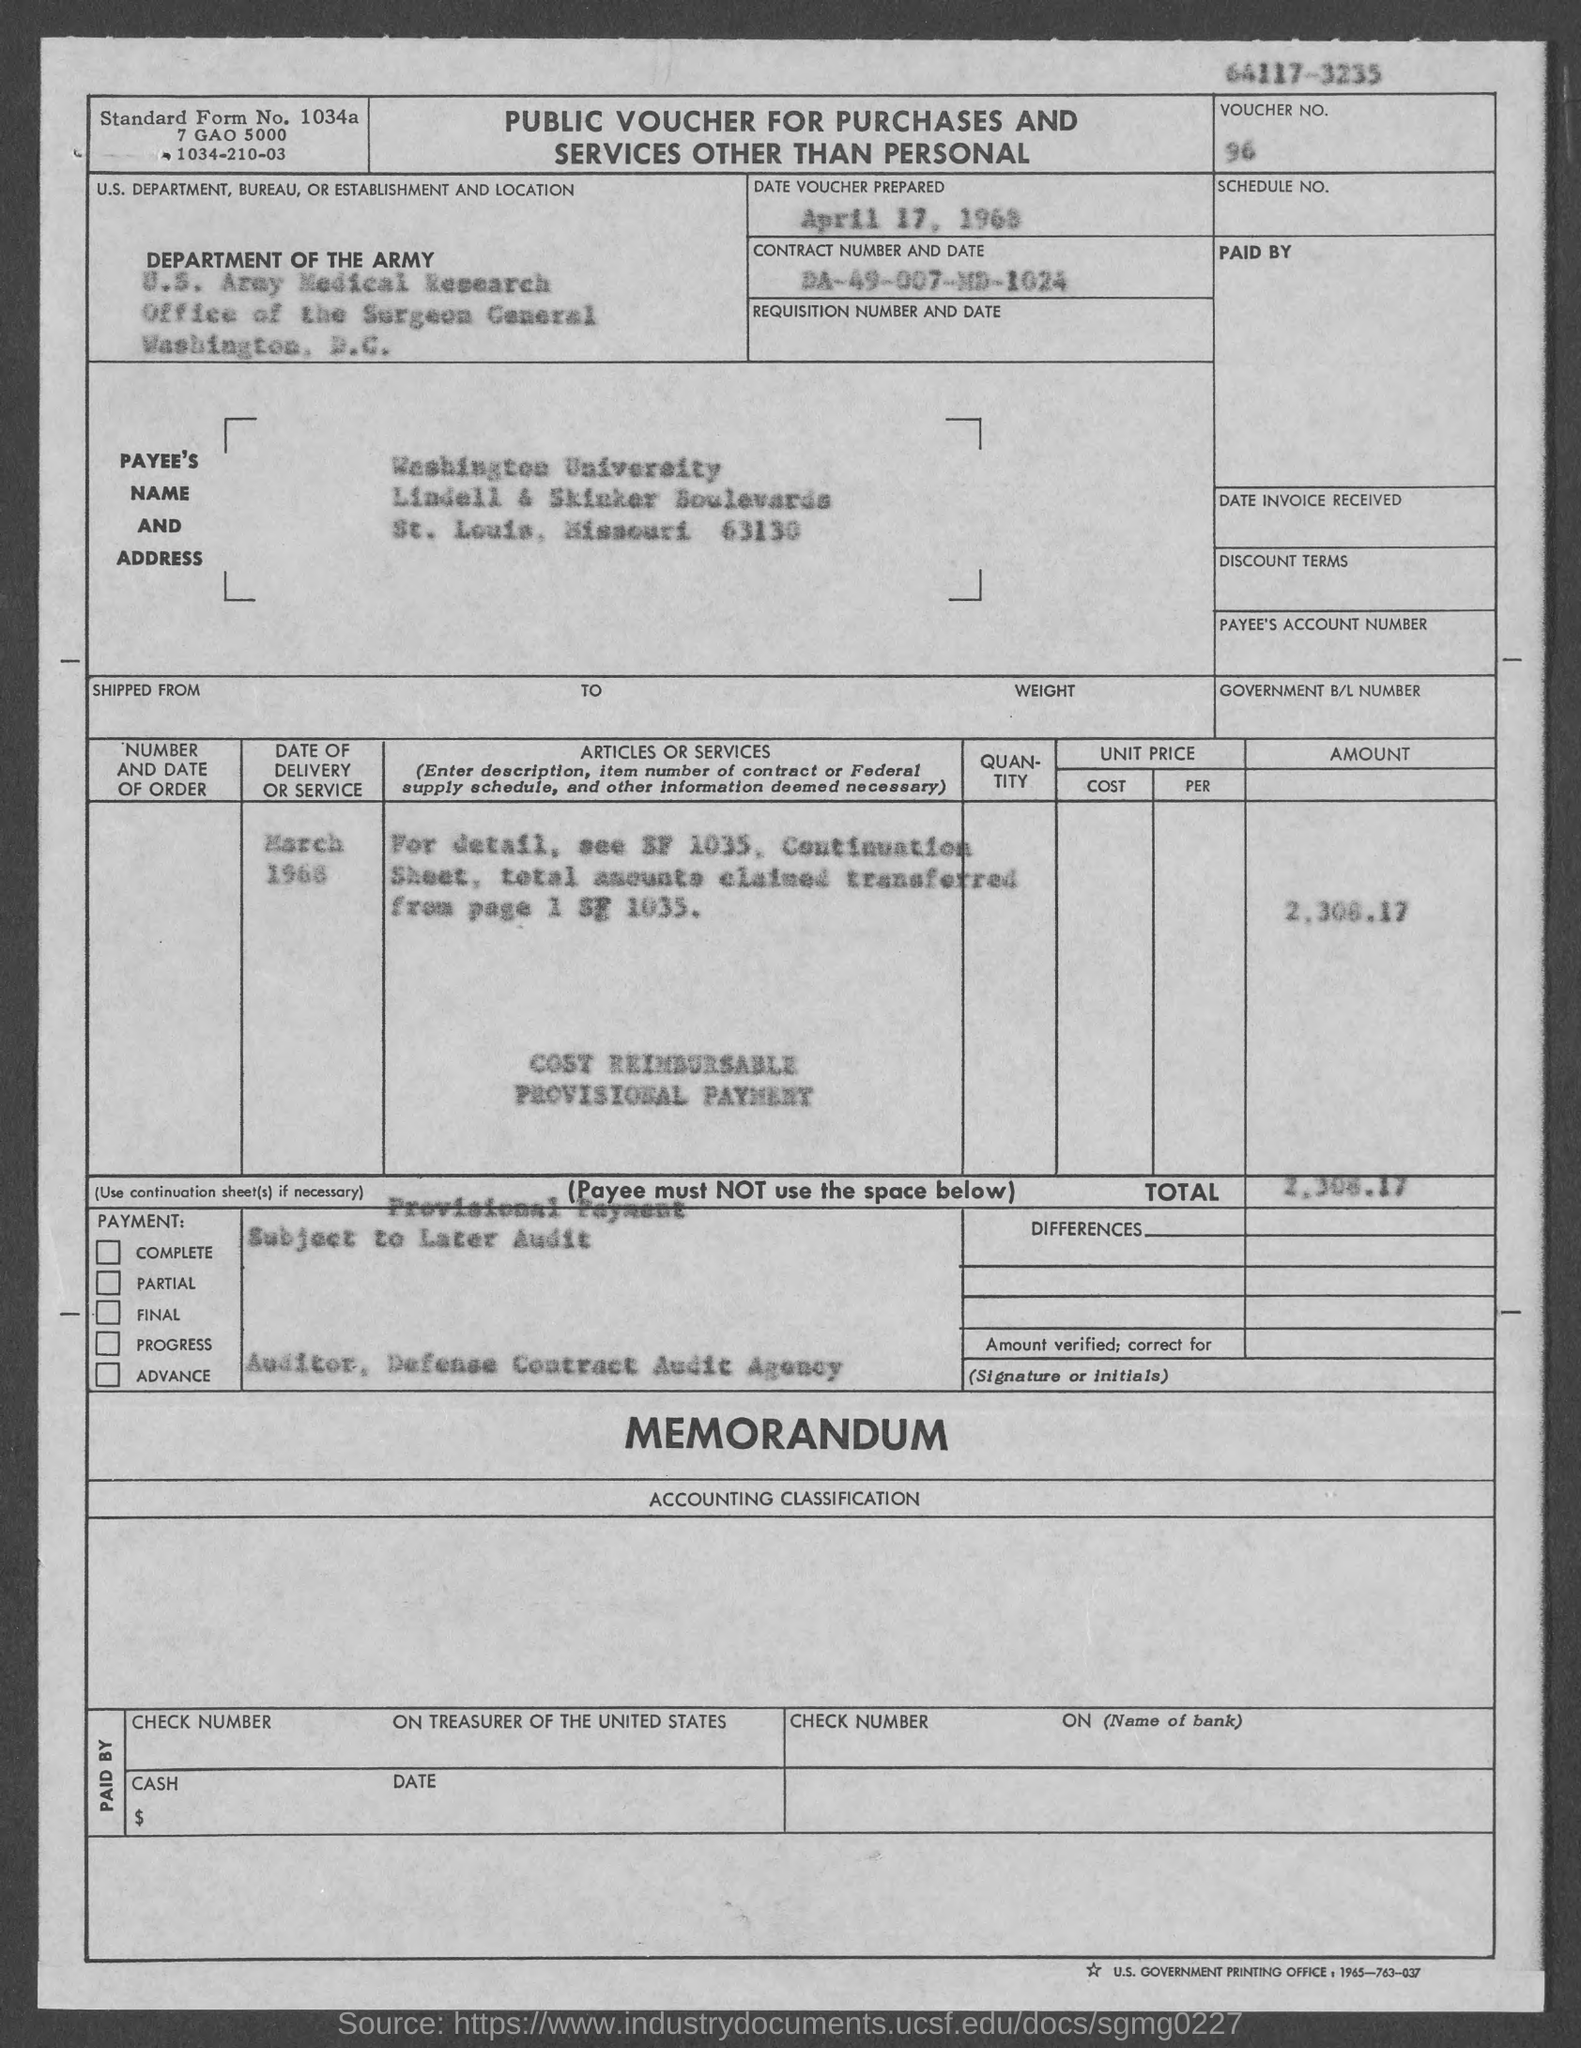Give some essential details in this illustration. The payee's zip code is 63130. The voucher number is 96... The voucher was prepared on April 17, 1968. The main heading on the table is "Public Voucher for Purchases and Services Other than Personal. 